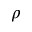<formula> <loc_0><loc_0><loc_500><loc_500>\rho</formula> 